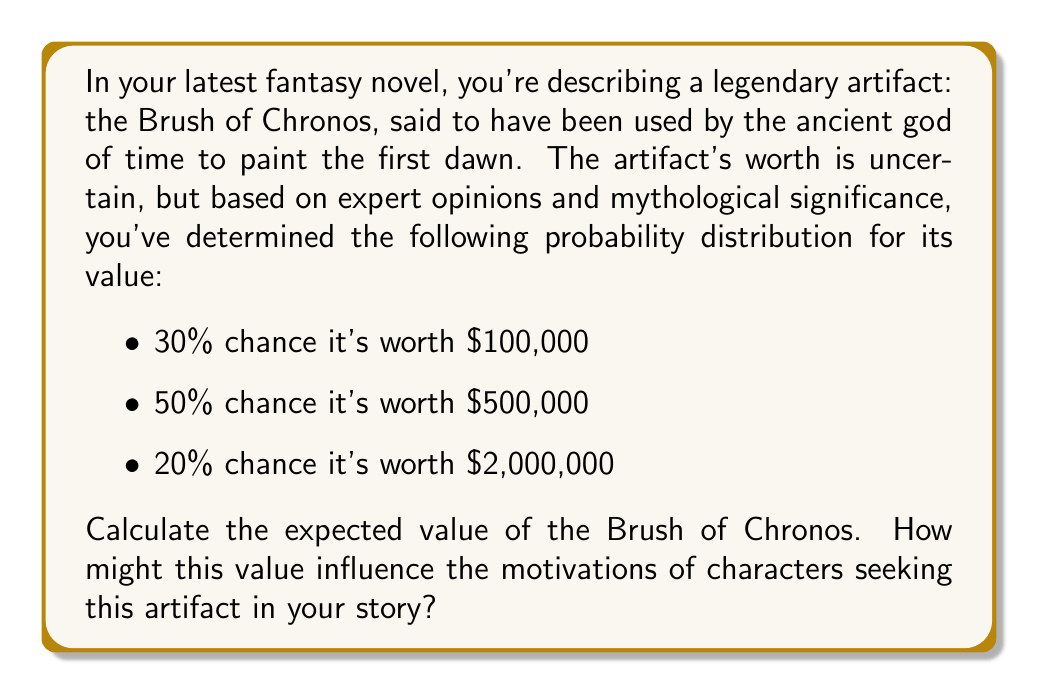Could you help me with this problem? To calculate the expected value of the Brush of Chronos, we need to use the concept of expected value from probability theory. The expected value is the sum of each possible outcome multiplied by its probability.

Let's define our probability distribution:

$P(X = 100,000) = 0.30$
$P(X = 500,000) = 0.50$
$P(X = 2,000,000) = 0.20$

The formula for expected value is:

$$ E(X) = \sum_{i=1}^{n} x_i \cdot P(X = x_i) $$

Where $x_i$ are the possible values and $P(X = x_i)$ are their respective probabilities.

Let's calculate:

$$ \begin{align*}
E(X) &= 100,000 \cdot 0.30 + 500,000 \cdot 0.50 + 2,000,000 \cdot 0.20 \\
&= 30,000 + 250,000 + 400,000 \\
&= 680,000
\end{align*} $$

Therefore, the expected value of the Brush of Chronos is $680,000.

This value could significantly influence character motivations in your story. For instance:

1. It provides a concrete figure for the artifact's worth, which could drive treasure hunters or collectors to seek it out.
2. The high expected value might justify dangerous quests or elaborate heists in your plot.
3. Characters might debate whether to sell the artifact or keep it for its mythological significance, creating moral dilemmas.
4. The variance in possible values (from $100,000 to $2,000,000) could create tension and risk-taking behavior among characters.
Answer: The expected value of the Brush of Chronos is $680,000. 